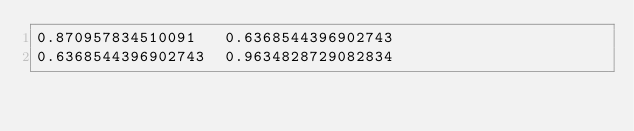<code> <loc_0><loc_0><loc_500><loc_500><_C_>0.870957834510091	0.6368544396902743
0.6368544396902743	0.9634828729082834
</code> 